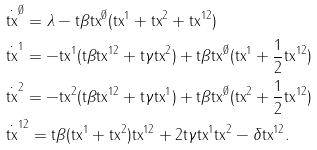<formula> <loc_0><loc_0><loc_500><loc_500>& \dot { \tt t x } ^ { \emptyset } = \lambda - \tt t \beta \tt t x ^ { \emptyset } ( \tt t x ^ { 1 } + \tt t x ^ { 2 } + \tt t x ^ { 1 2 } ) \\ & \dot { \tt t x } ^ { 1 } = - \tt t x ^ { 1 } ( \tt t \beta \tt t x ^ { 1 2 } + \tt t \gamma \tt t x ^ { 2 } ) + \tt t \beta \tt t x ^ { \emptyset } ( \tt t x ^ { 1 } + \frac { 1 } { 2 } \tt t x ^ { 1 2 } ) \\ & \dot { \tt t x } ^ { 2 } = - \tt t x ^ { 2 } ( \tt t \beta \tt t x ^ { 1 2 } + \tt t \gamma \tt t x ^ { 1 } ) + \tt t \beta \tt t x ^ { \emptyset } ( \tt t x ^ { 2 } + \frac { 1 } { 2 } \tt t x ^ { 1 2 } ) \\ & \dot { \tt t x } ^ { 1 2 } = \tt t \beta ( \tt t x ^ { 1 } + \tt t x ^ { 2 } ) \tt t x ^ { 1 2 } + 2 \tt t \gamma \tt t x ^ { 1 } \tt t x ^ { 2 } - \delta \tt t x ^ { 1 2 } .</formula> 